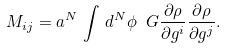Convert formula to latex. <formula><loc_0><loc_0><loc_500><loc_500>M _ { i j } = a ^ { N } \, \int \, d ^ { N } \phi \ G \frac { \partial \rho } { \partial g ^ { i } } \frac { \partial \rho } { \partial g ^ { j } } .</formula> 